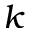<formula> <loc_0><loc_0><loc_500><loc_500>k</formula> 